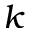<formula> <loc_0><loc_0><loc_500><loc_500>k</formula> 